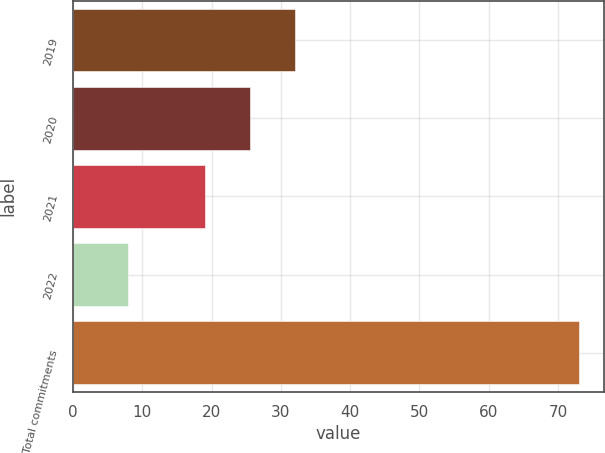Convert chart. <chart><loc_0><loc_0><loc_500><loc_500><bar_chart><fcel>2019<fcel>2020<fcel>2021<fcel>2022<fcel>Total commitments<nl><fcel>32<fcel>25.5<fcel>19<fcel>8<fcel>73<nl></chart> 